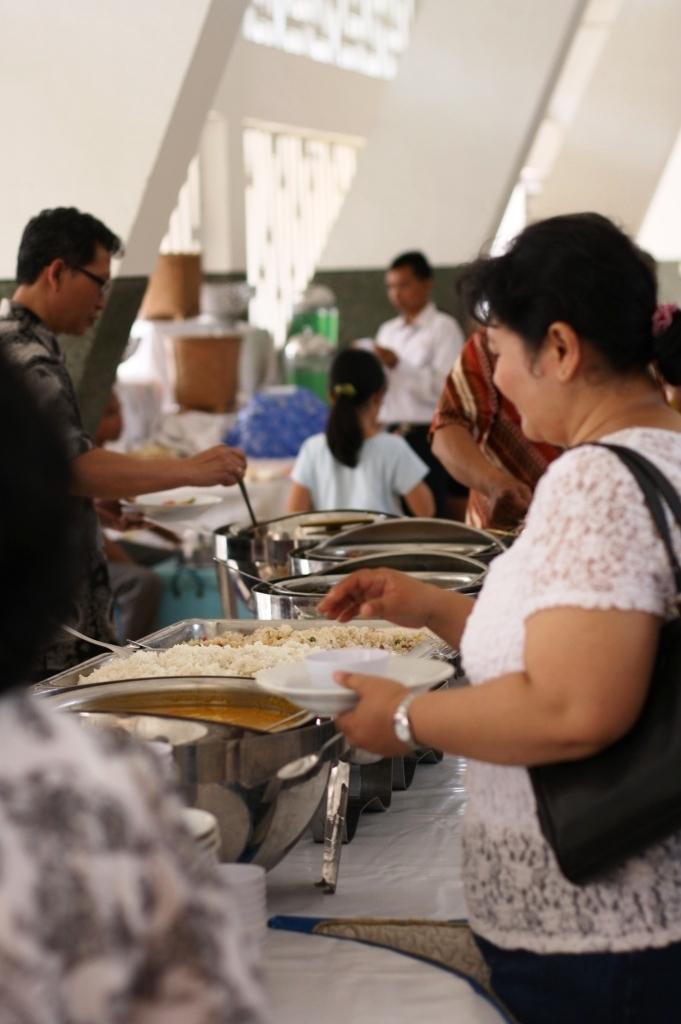Can you describe this image briefly? In this image we can see a woman on the right side. She is holding a plate in her left hand. Here we can see the watch. Here we can see the handbag on the right side. Here we can see the food items in a stainless steel bowls. Here we can see the tables which are covered with a white cloth. Here we can see a man on the left side. In the background, we can see three persons. 